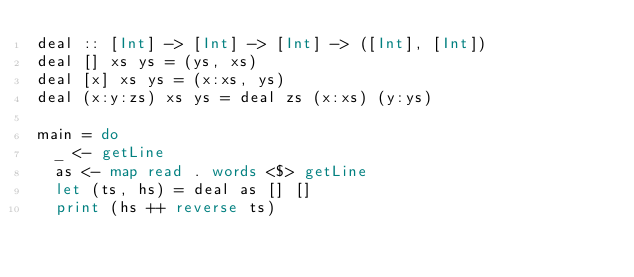<code> <loc_0><loc_0><loc_500><loc_500><_Haskell_>deal :: [Int] -> [Int] -> [Int] -> ([Int], [Int])
deal [] xs ys = (ys, xs)
deal [x] xs ys = (x:xs, ys)
deal (x:y:zs) xs ys = deal zs (x:xs) (y:ys)
 
main = do
  _ <- getLine
  as <- map read . words <$> getLine
  let (ts, hs) = deal as [] []
  print (hs ++ reverse ts)</code> 